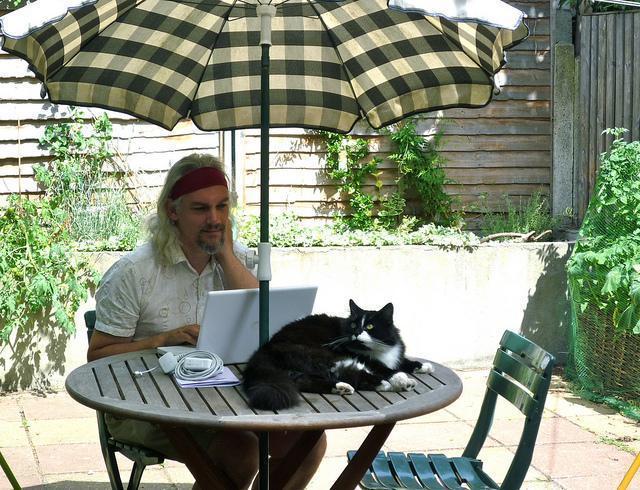Does the description: "The umbrella is above the dining table." accurately reflect the image?
Answer yes or no. Yes. Is the caption "The person is touching the umbrella." a true representation of the image?
Answer yes or no. No. 